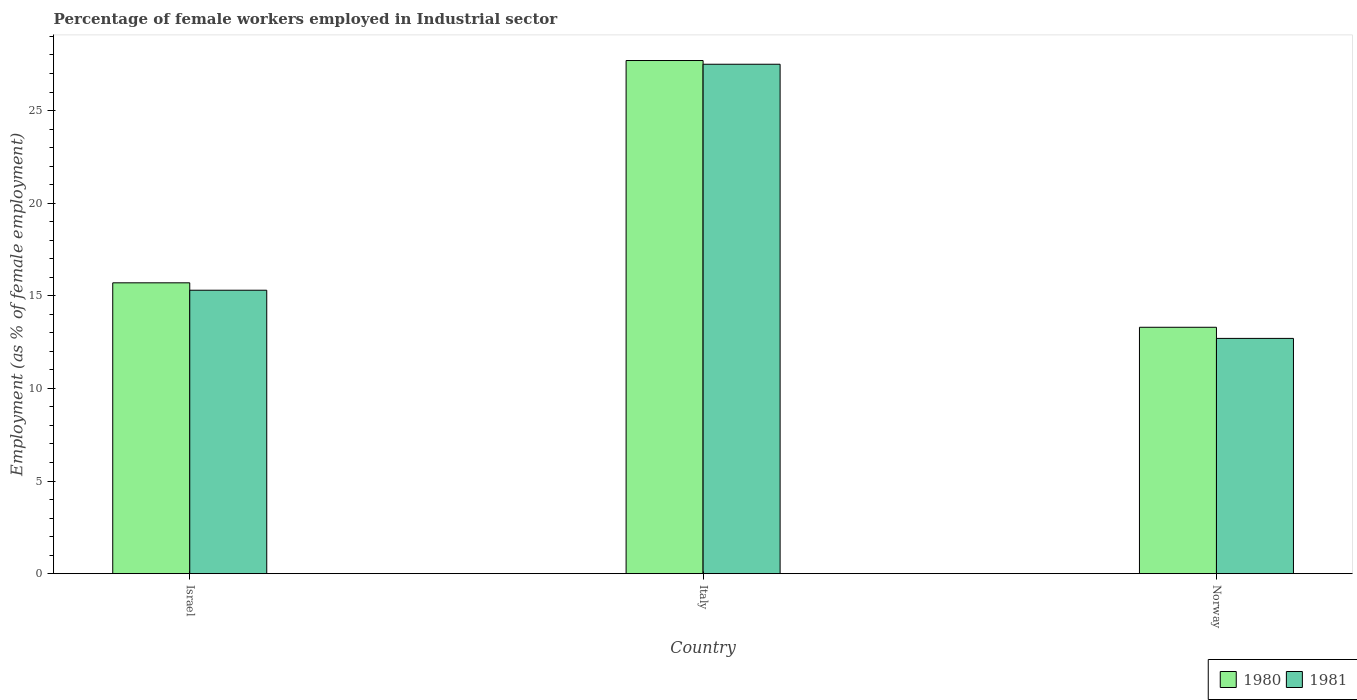Are the number of bars per tick equal to the number of legend labels?
Keep it short and to the point. Yes. How many bars are there on the 1st tick from the right?
Your response must be concise. 2. In how many cases, is the number of bars for a given country not equal to the number of legend labels?
Give a very brief answer. 0. Across all countries, what is the maximum percentage of females employed in Industrial sector in 1980?
Your answer should be compact. 27.7. Across all countries, what is the minimum percentage of females employed in Industrial sector in 1981?
Your response must be concise. 12.7. In which country was the percentage of females employed in Industrial sector in 1980 maximum?
Keep it short and to the point. Italy. In which country was the percentage of females employed in Industrial sector in 1980 minimum?
Provide a short and direct response. Norway. What is the total percentage of females employed in Industrial sector in 1981 in the graph?
Provide a short and direct response. 55.5. What is the difference between the percentage of females employed in Industrial sector in 1981 in Israel and that in Norway?
Keep it short and to the point. 2.6. What is the difference between the percentage of females employed in Industrial sector of/in 1980 and percentage of females employed in Industrial sector of/in 1981 in Israel?
Offer a very short reply. 0.4. What is the ratio of the percentage of females employed in Industrial sector in 1981 in Italy to that in Norway?
Give a very brief answer. 2.17. Is the difference between the percentage of females employed in Industrial sector in 1980 in Italy and Norway greater than the difference between the percentage of females employed in Industrial sector in 1981 in Italy and Norway?
Your answer should be compact. No. What is the difference between the highest and the second highest percentage of females employed in Industrial sector in 1980?
Provide a succinct answer. 14.4. What is the difference between the highest and the lowest percentage of females employed in Industrial sector in 1981?
Give a very brief answer. 14.8. Is the sum of the percentage of females employed in Industrial sector in 1980 in Italy and Norway greater than the maximum percentage of females employed in Industrial sector in 1981 across all countries?
Offer a terse response. Yes. What does the 1st bar from the left in Italy represents?
Offer a terse response. 1980. How many countries are there in the graph?
Offer a terse response. 3. What is the difference between two consecutive major ticks on the Y-axis?
Give a very brief answer. 5. Does the graph contain any zero values?
Provide a succinct answer. No. What is the title of the graph?
Your answer should be very brief. Percentage of female workers employed in Industrial sector. Does "1985" appear as one of the legend labels in the graph?
Offer a terse response. No. What is the label or title of the X-axis?
Your answer should be very brief. Country. What is the label or title of the Y-axis?
Your response must be concise. Employment (as % of female employment). What is the Employment (as % of female employment) in 1980 in Israel?
Provide a succinct answer. 15.7. What is the Employment (as % of female employment) in 1981 in Israel?
Your response must be concise. 15.3. What is the Employment (as % of female employment) of 1980 in Italy?
Ensure brevity in your answer.  27.7. What is the Employment (as % of female employment) in 1981 in Italy?
Make the answer very short. 27.5. What is the Employment (as % of female employment) of 1980 in Norway?
Provide a short and direct response. 13.3. What is the Employment (as % of female employment) in 1981 in Norway?
Offer a very short reply. 12.7. Across all countries, what is the maximum Employment (as % of female employment) of 1980?
Offer a very short reply. 27.7. Across all countries, what is the minimum Employment (as % of female employment) of 1980?
Your answer should be compact. 13.3. Across all countries, what is the minimum Employment (as % of female employment) of 1981?
Ensure brevity in your answer.  12.7. What is the total Employment (as % of female employment) of 1980 in the graph?
Provide a short and direct response. 56.7. What is the total Employment (as % of female employment) in 1981 in the graph?
Your response must be concise. 55.5. What is the difference between the Employment (as % of female employment) of 1981 in Israel and that in Italy?
Make the answer very short. -12.2. What is the difference between the Employment (as % of female employment) of 1980 in Italy and that in Norway?
Your answer should be compact. 14.4. What is the difference between the Employment (as % of female employment) in 1980 in Israel and the Employment (as % of female employment) in 1981 in Norway?
Offer a terse response. 3. What is the difference between the Employment (as % of female employment) in 1980 in Italy and the Employment (as % of female employment) in 1981 in Norway?
Provide a short and direct response. 15. What is the average Employment (as % of female employment) of 1981 per country?
Make the answer very short. 18.5. What is the difference between the Employment (as % of female employment) in 1980 and Employment (as % of female employment) in 1981 in Israel?
Provide a short and direct response. 0.4. What is the difference between the Employment (as % of female employment) in 1980 and Employment (as % of female employment) in 1981 in Italy?
Make the answer very short. 0.2. What is the difference between the Employment (as % of female employment) in 1980 and Employment (as % of female employment) in 1981 in Norway?
Offer a very short reply. 0.6. What is the ratio of the Employment (as % of female employment) of 1980 in Israel to that in Italy?
Offer a very short reply. 0.57. What is the ratio of the Employment (as % of female employment) in 1981 in Israel to that in Italy?
Your response must be concise. 0.56. What is the ratio of the Employment (as % of female employment) of 1980 in Israel to that in Norway?
Provide a succinct answer. 1.18. What is the ratio of the Employment (as % of female employment) in 1981 in Israel to that in Norway?
Ensure brevity in your answer.  1.2. What is the ratio of the Employment (as % of female employment) in 1980 in Italy to that in Norway?
Offer a terse response. 2.08. What is the ratio of the Employment (as % of female employment) in 1981 in Italy to that in Norway?
Keep it short and to the point. 2.17. What is the difference between the highest and the second highest Employment (as % of female employment) in 1980?
Keep it short and to the point. 12. What is the difference between the highest and the second highest Employment (as % of female employment) in 1981?
Provide a succinct answer. 12.2. What is the difference between the highest and the lowest Employment (as % of female employment) in 1980?
Make the answer very short. 14.4. What is the difference between the highest and the lowest Employment (as % of female employment) in 1981?
Your answer should be very brief. 14.8. 